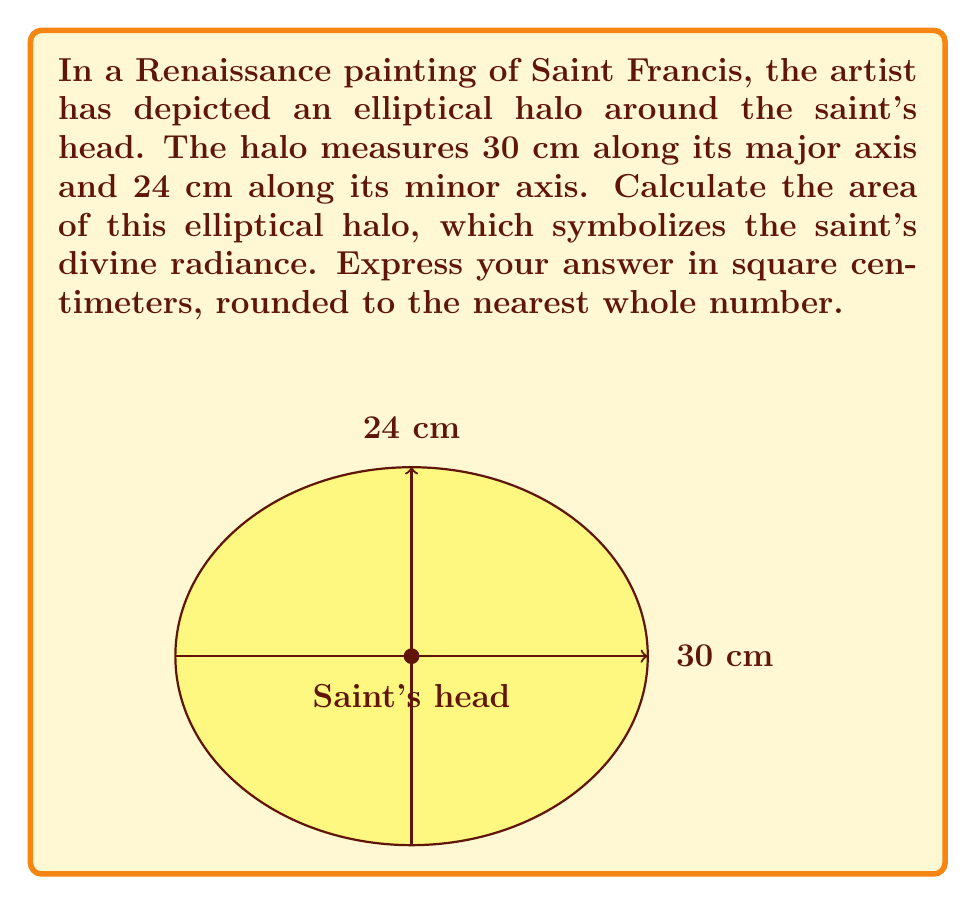Solve this math problem. To find the area of an elliptical halo, we need to use the formula for the area of an ellipse:

$$ A = \pi ab $$

Where:
$A$ is the area of the ellipse
$a$ is half the length of the major axis
$b$ is half the length of the minor axis

Given:
- Major axis = 30 cm
- Minor axis = 24 cm

Step 1: Calculate $a$ and $b$
$a = 30 \div 2 = 15$ cm
$b = 24 \div 2 = 12$ cm

Step 2: Apply the formula
$$ A = \pi ab $$
$$ A = \pi \cdot 15 \cdot 12 $$

Step 3: Calculate the result
$$ A = 180\pi \approx 565.49 \text{ cm}^2 $$

Step 4: Round to the nearest whole number
$565.49 \text{ cm}^2 \approx 565 \text{ cm}^2$

Therefore, the area of the elliptical halo is approximately 565 square centimeters.
Answer: 565 cm² 